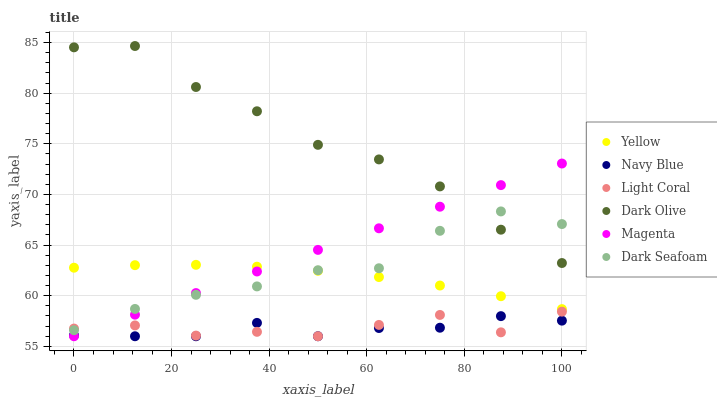Does Navy Blue have the minimum area under the curve?
Answer yes or no. Yes. Does Dark Olive have the maximum area under the curve?
Answer yes or no. Yes. Does Yellow have the minimum area under the curve?
Answer yes or no. No. Does Yellow have the maximum area under the curve?
Answer yes or no. No. Is Magenta the smoothest?
Answer yes or no. Yes. Is Dark Olive the roughest?
Answer yes or no. Yes. Is Yellow the smoothest?
Answer yes or no. No. Is Yellow the roughest?
Answer yes or no. No. Does Navy Blue have the lowest value?
Answer yes or no. Yes. Does Yellow have the lowest value?
Answer yes or no. No. Does Dark Olive have the highest value?
Answer yes or no. Yes. Does Yellow have the highest value?
Answer yes or no. No. Is Navy Blue less than Dark Seafoam?
Answer yes or no. Yes. Is Yellow greater than Navy Blue?
Answer yes or no. Yes. Does Light Coral intersect Navy Blue?
Answer yes or no. Yes. Is Light Coral less than Navy Blue?
Answer yes or no. No. Is Light Coral greater than Navy Blue?
Answer yes or no. No. Does Navy Blue intersect Dark Seafoam?
Answer yes or no. No. 